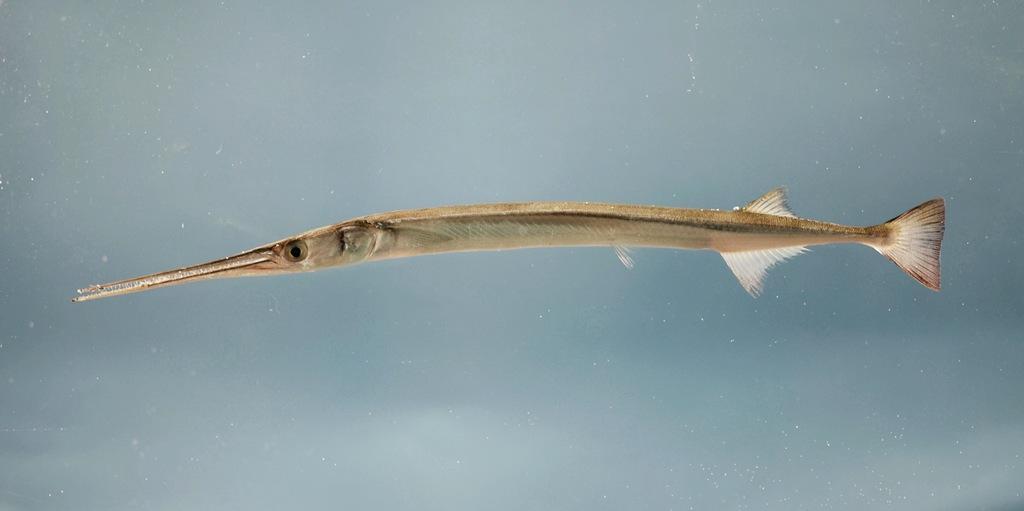How would you summarize this image in a sentence or two? In this picture I can see a fish in the water. 